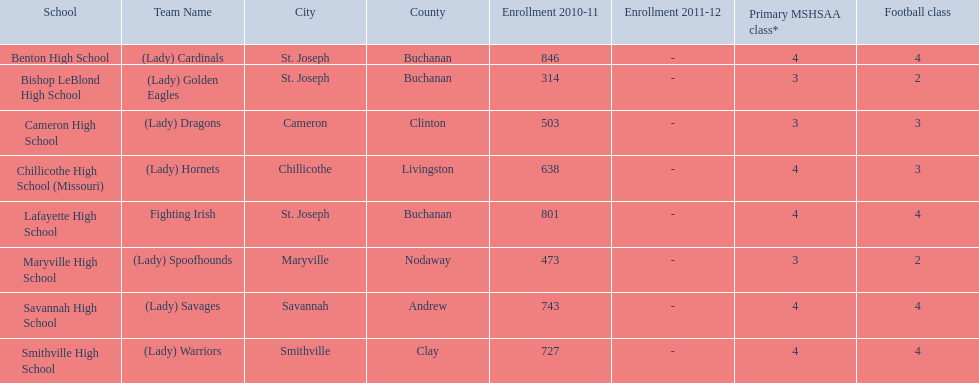How many are enrolled at each school? Benton High School, 846, Bishop LeBlond High School, 314, Cameron High School, 503, Chillicothe High School (Missouri), 638, Lafayette High School, 801, Maryville High School, 473, Savannah High School, 743, Smithville High School, 727. Which school has at only three football classes? Cameron High School, 3, Chillicothe High School (Missouri), 3. Which school has 638 enrolled and 3 football classes? Chillicothe High School (Missouri). 